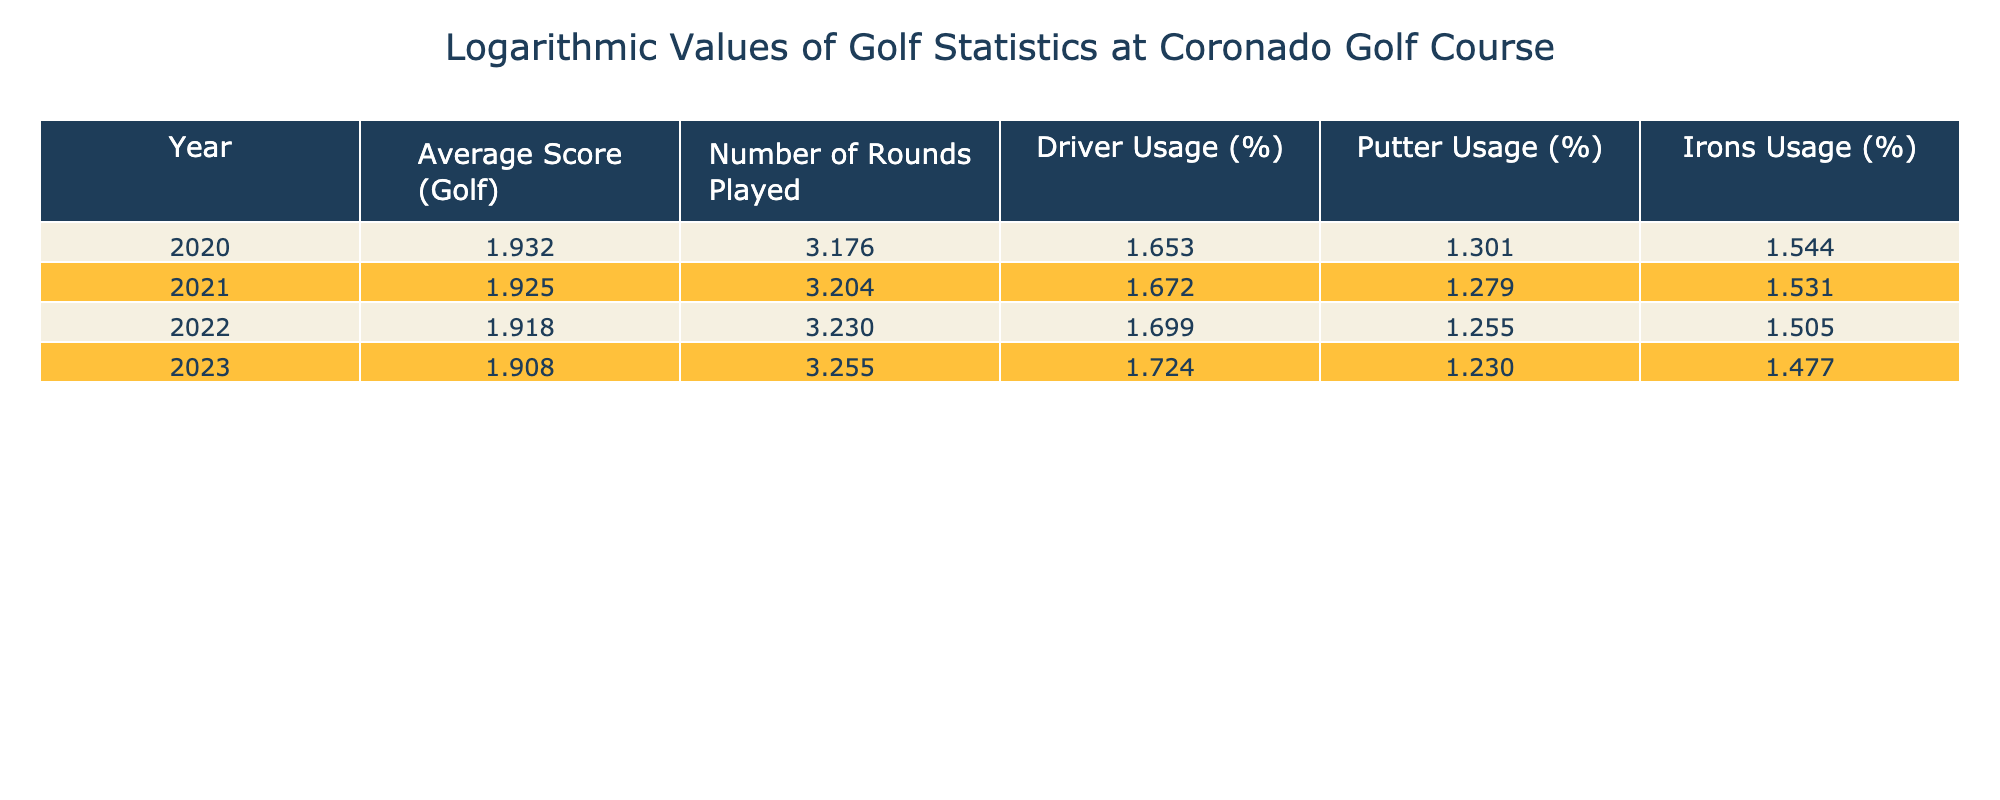What was the average score in 2022? Referring to the table, the average score listed for the year 2022 is 82.8.
Answer: 82.8 What percentage of rounds played increased from 2020 to 2023? The number of rounds played in 2020 was 1500 and in 2023 it was 1800. The increase is calculated as (1800 - 1500) / 1500 * 100 = 20%.
Answer: 20% Did the driver usage percentage decrease from 2021 to 2023? In 2021, driver usage was 47% and in 2023 it was 53%. Since 53% is greater than 47%, driver usage did not decrease.
Answer: No What was the percentage difference in putter usage between 2020 and 2023? Putter usage was 20% in 2020 and 17% in 2023. The difference is calculated as 20% - 17% = 3%. So the percentage difference is 3%.
Answer: 3% Is the average score for 2021 higher than the average score for 2022? The average score for 2021 is 84.2 and for 2022 it is 82.8. Since 84.2 is greater than 82.8, the statement is true.
Answer: Yes What is the overall average score from 2020 to 2023? The average score for the years 2020, 2021, 2022, and 2023 can be found by calculating (85.5 + 84.2 + 82.8 + 81.0) / 4 = 83.375.
Answer: 83.375 What was the trend in irons usage from 2020 to 2023? Irons usage started at 35% in 2020 and decreased to 30% in 2023, indicating a downward trend.
Answer: Downward trend Was the number of rounds played in 2021 lower than in 2022? The number of rounds played was 1600 in 2021 and 1700 in 2022, therefore it was not lower in 2021.
Answer: No 